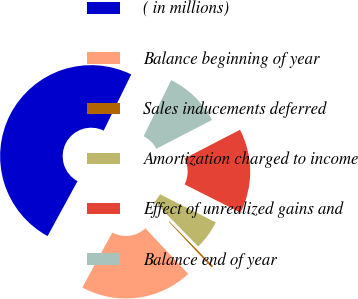<chart> <loc_0><loc_0><loc_500><loc_500><pie_chart><fcel>( in millions)<fcel>Balance beginning of year<fcel>Sales inducements deferred<fcel>Amortization charged to income<fcel>Effect of unrealized gains and<fcel>Balance end of year<nl><fcel>49.31%<fcel>19.93%<fcel>0.34%<fcel>5.24%<fcel>15.03%<fcel>10.14%<nl></chart> 